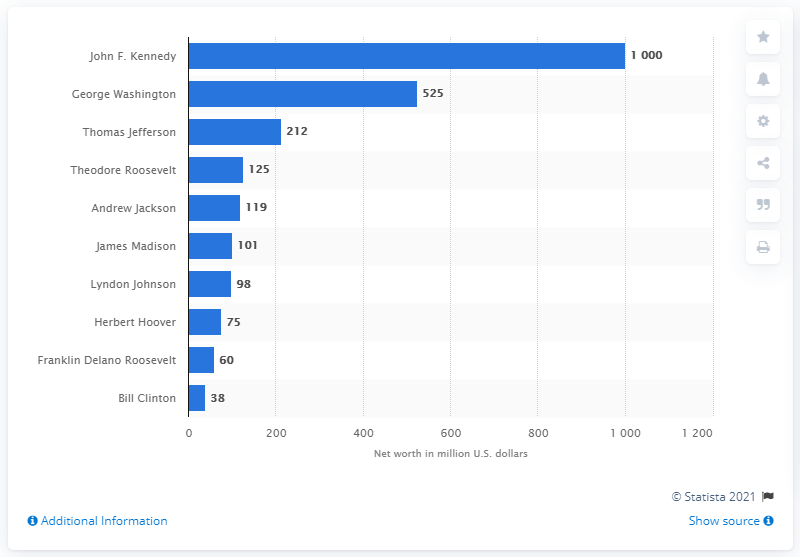Identify some key points in this picture. John F. Kennedy was the richest U.S. president in 2010. 